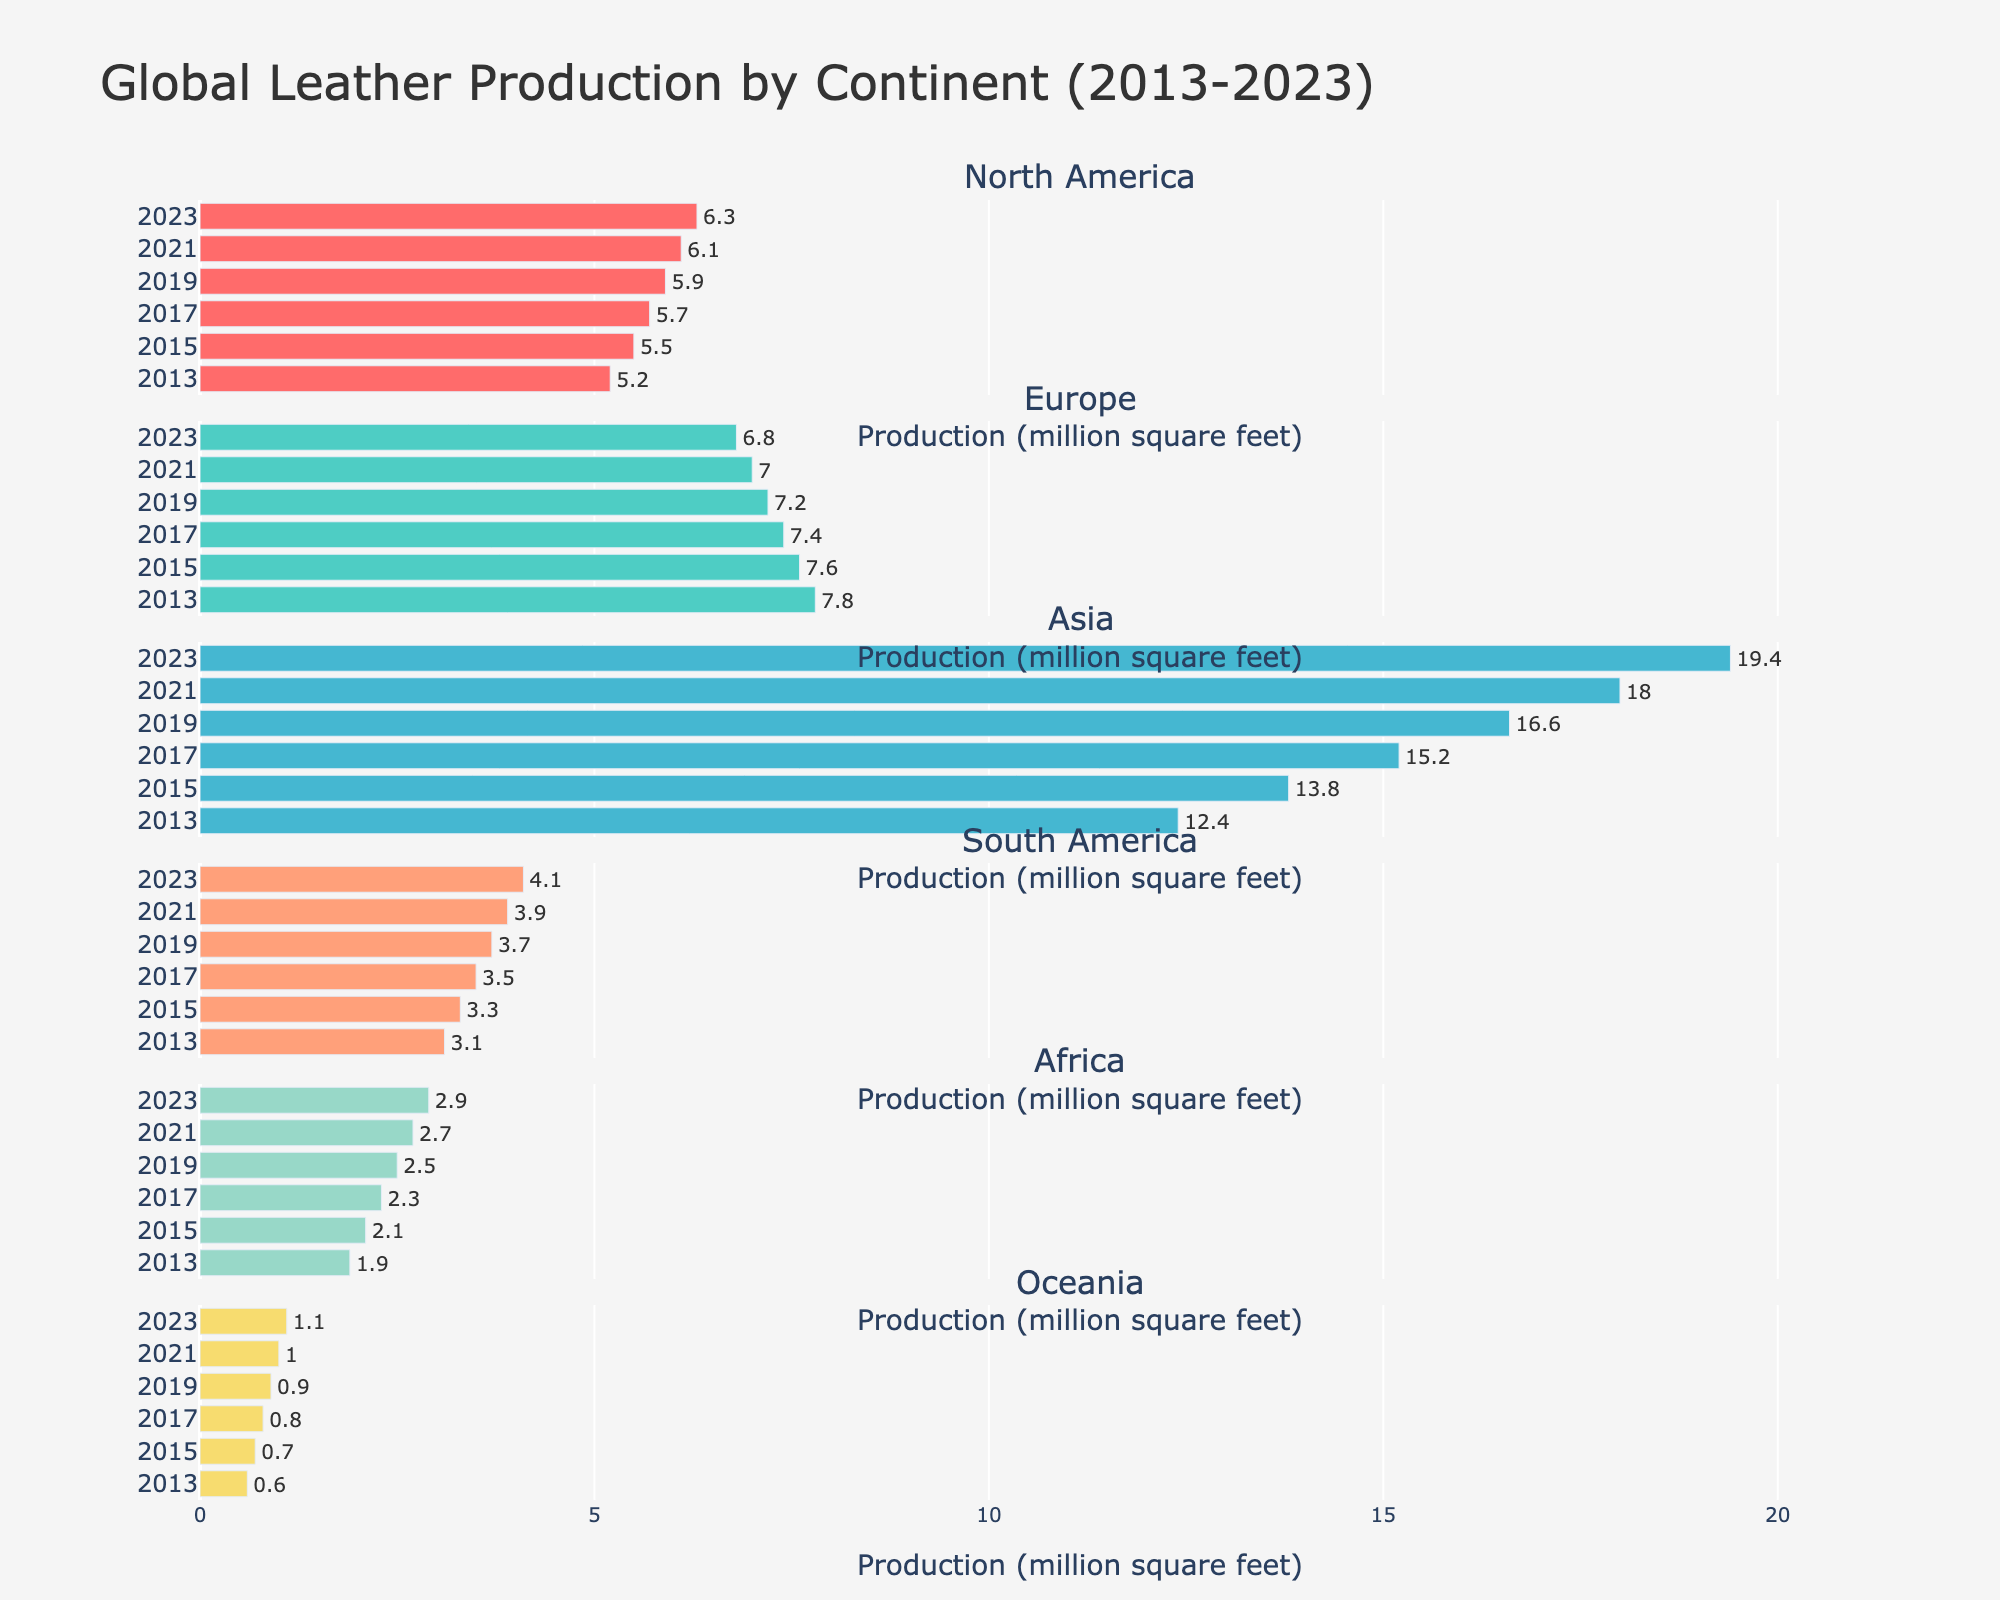What is the title of the figure? The title is usually found at the top of the figure and is a concise summary of what the figure depicts. In this figure, it is prominently displayed.
Answer: Global Leather Production by Continent (2013-2023) Which continent had the highest leather production in 2023? To determine this, look at the bars representing data for the year 2023 and identify the longest one.
Answer: Asia What is the range of leather production in South America over the years? To find the range, subtract the smallest production value for South America from the largest one, which can be seen by comparing the lengths of the bars for each year. The smallest value is 3.1 (2013), and the largest is 4.1 (2023), so the range is 4.1 - 3.1.
Answer: 1.0 million square feet Which continents' leather production increased by more than 1 million square feet from 2013 to 2023? Compare the bars from 2013 and 2023 for each continent. Subtract the 2013 value from the 2023 value and check if the difference is greater than 1. Continents satisfying this condition are Asia (19.4-12.4 = 7), Africa (2.9-1.9 = 1), and South America (4.1-3.1 = 1).
Answer: Asia, Africa, South America What trend can you observe about Europe's leather production from 2013 to 2023? Look at the bars for Europe across the years and compare their lengths. Notice if they generally increase, decrease, or stay the same. The bars for Europe show a decreasing trend from 7.8 in 2013 to 6.8 in 2023.
Answer: Decreasing Which year saw the highest leather production in North America? Check the bars for North America across all the years and identify the longest one. The bar for 2023 is the longest, showing a value of 6.3.
Answer: 2023 Comparing 2019 and 2021, which continent had the most significant increase in leather production? Look at the difference in bar lengths between 2019 and 2021 for each continent, and identify the largest increase. Asia increased from 16.6 to 18.0, which is the most significant at 1.4 million square feet.
Answer: Asia How does the production in Oceania in 2023 compare to that in 2021? Compare the bars for Oceania between the years 2021 and 2023. The bar length increased from 1.0 to 1.1.
Answer: Increased by 0.1 million square feet What is the average leather production in Africa from 2013 to 2023? Calculate the average by summing up the values for Africa over the years and dividing by the number of years: (1.9 + 2.1 + 2.3 + 2.5 + 2.7 + 2.9) / 6 = 2.4.
Answer: 2.4 million square feet 